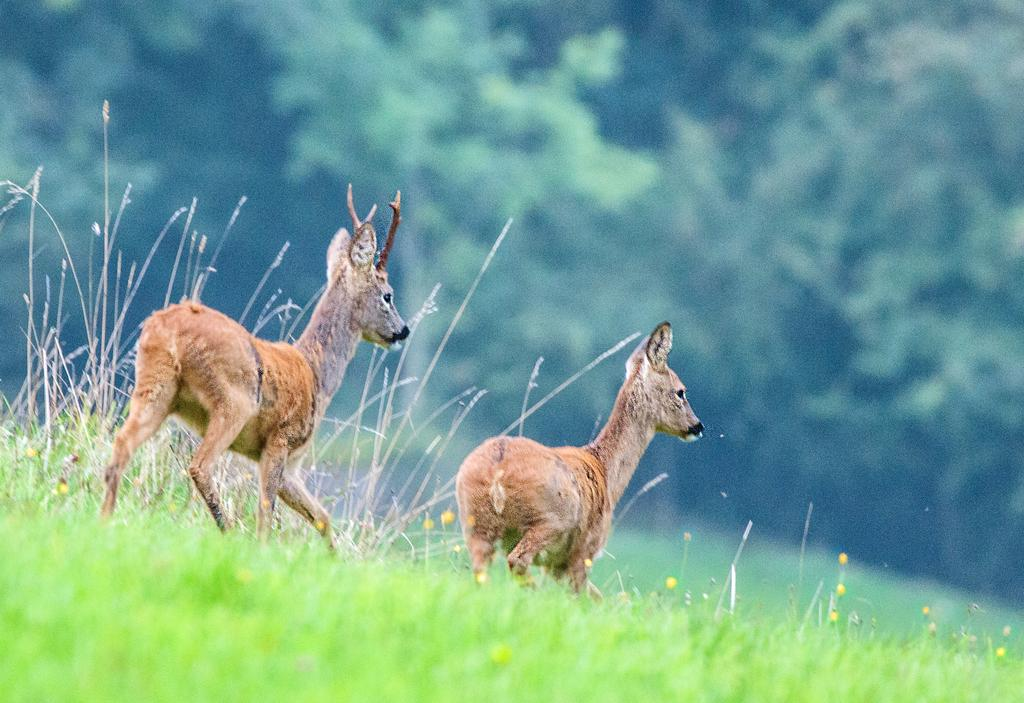What can be seen on the ground in the image? There are two small tears on the ground in the image. What type of flowers are present on the grass? There are yellow flowers on the grass in the image. What can be seen in the background of the image? There are many trees in the background of the image. How many sneezes can be heard in the image? There are no sneezes present in the image; it is a still image with no audible sounds. What type of prose is being written by the flowers in the image? There are no flowers writing prose in the image; the flowers are simply growing on the grass. 